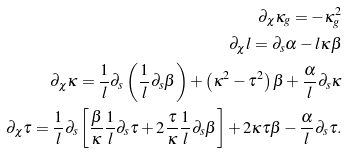<formula> <loc_0><loc_0><loc_500><loc_500>\partial _ { \chi } \kappa _ { g } = - \kappa _ { g } ^ { 2 } \\ \partial _ { \chi } l = \partial _ { s } \alpha - l \kappa \beta \\ \partial _ { \chi } \kappa = \frac { 1 } { l } \partial _ { s } \left ( \frac { 1 } { l } \partial _ { s } \beta \right ) + \left ( \kappa ^ { 2 } - \tau ^ { 2 } \right ) \beta + \frac { \alpha } { l } \partial _ { s } \kappa \\ \partial _ { \chi } \tau = \frac { 1 } { l } \partial _ { s } \left [ \frac { \beta } { \kappa } \frac { 1 } { l } \partial _ { s } \tau + 2 \frac { \tau } { \kappa } \frac { 1 } { l } \partial _ { s } \beta \right ] + 2 \kappa \tau \beta - \frac { \alpha } { l } \partial _ { s } \tau .</formula> 